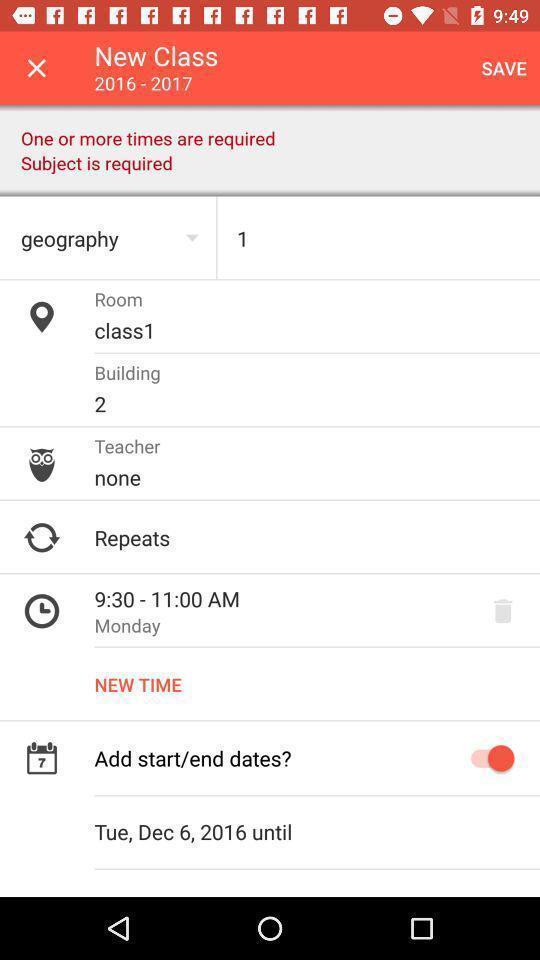Please provide a description for this image. Page displays to add new class details in app. 